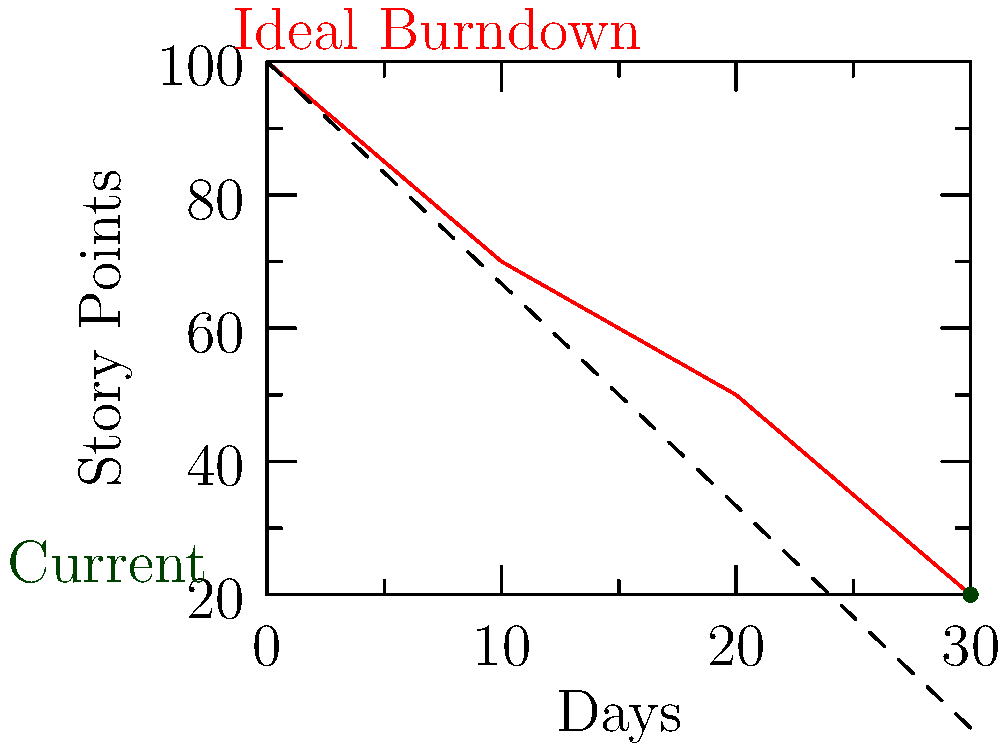Based on the burndown chart shown, if the project maintains its current progress rate, approximately how many additional days will be needed to complete the project beyond the initial 30-day estimate? To solve this problem, we need to follow these steps:

1. Identify the current progress:
   - At day 30, there are 20 story points remaining.

2. Calculate the average daily progress:
   - Total story points completed = 100 - 20 = 80 points
   - Number of days elapsed = 30
   - Average daily progress = 80 / 30 ≈ 2.67 points/day

3. Estimate remaining time:
   - Remaining story points = 20
   - Estimated additional days = 20 / 2.67 ≈ 7.5 days

4. Round up to the nearest whole day:
   - Additional days needed ≈ 8 days

Therefore, if the project maintains its current progress rate, it will need approximately 8 additional days beyond the initial 30-day estimate to complete the project.
Answer: 8 days 